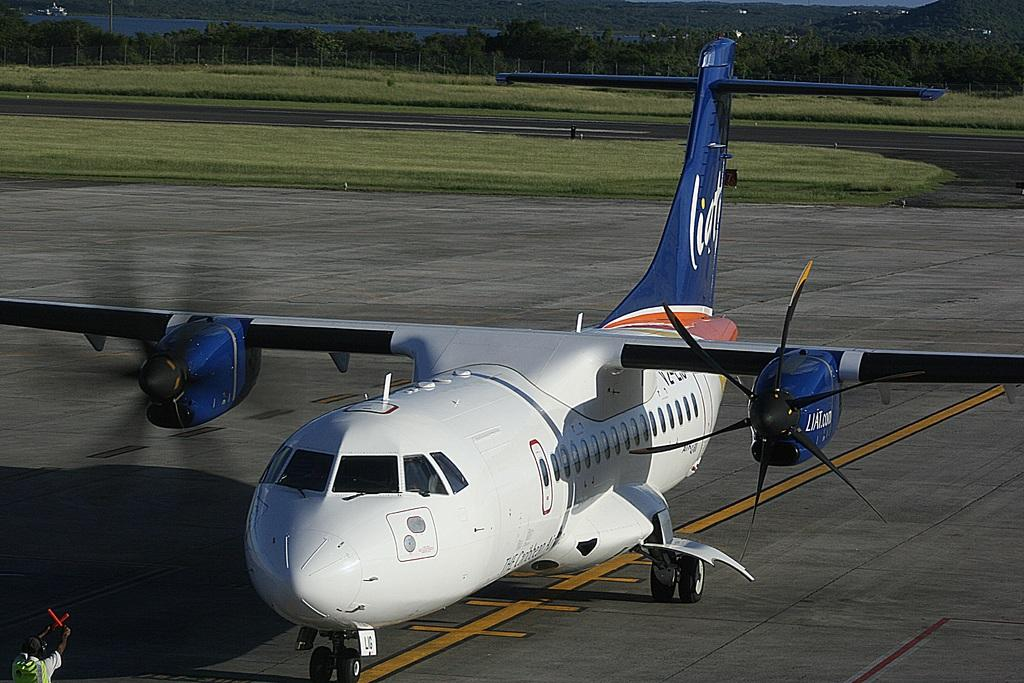What is the unusual object on the road in the image? There is an airplane on the road in the image. Can you describe the person located at the left bottom of the image? There is a man at the left bottom of the image. What type of natural environment is visible in the background of the image? There is grass, trees, and water visible in the background of the image. What architectural feature can be seen in the background of the image? There is a fence in the background of the image. What type of gold object is visible in the image? There is no gold object present in the image. Can you tell me how many times the man falls in the image? The man is not shown falling in the image; he is standing at the left bottom of the image. 